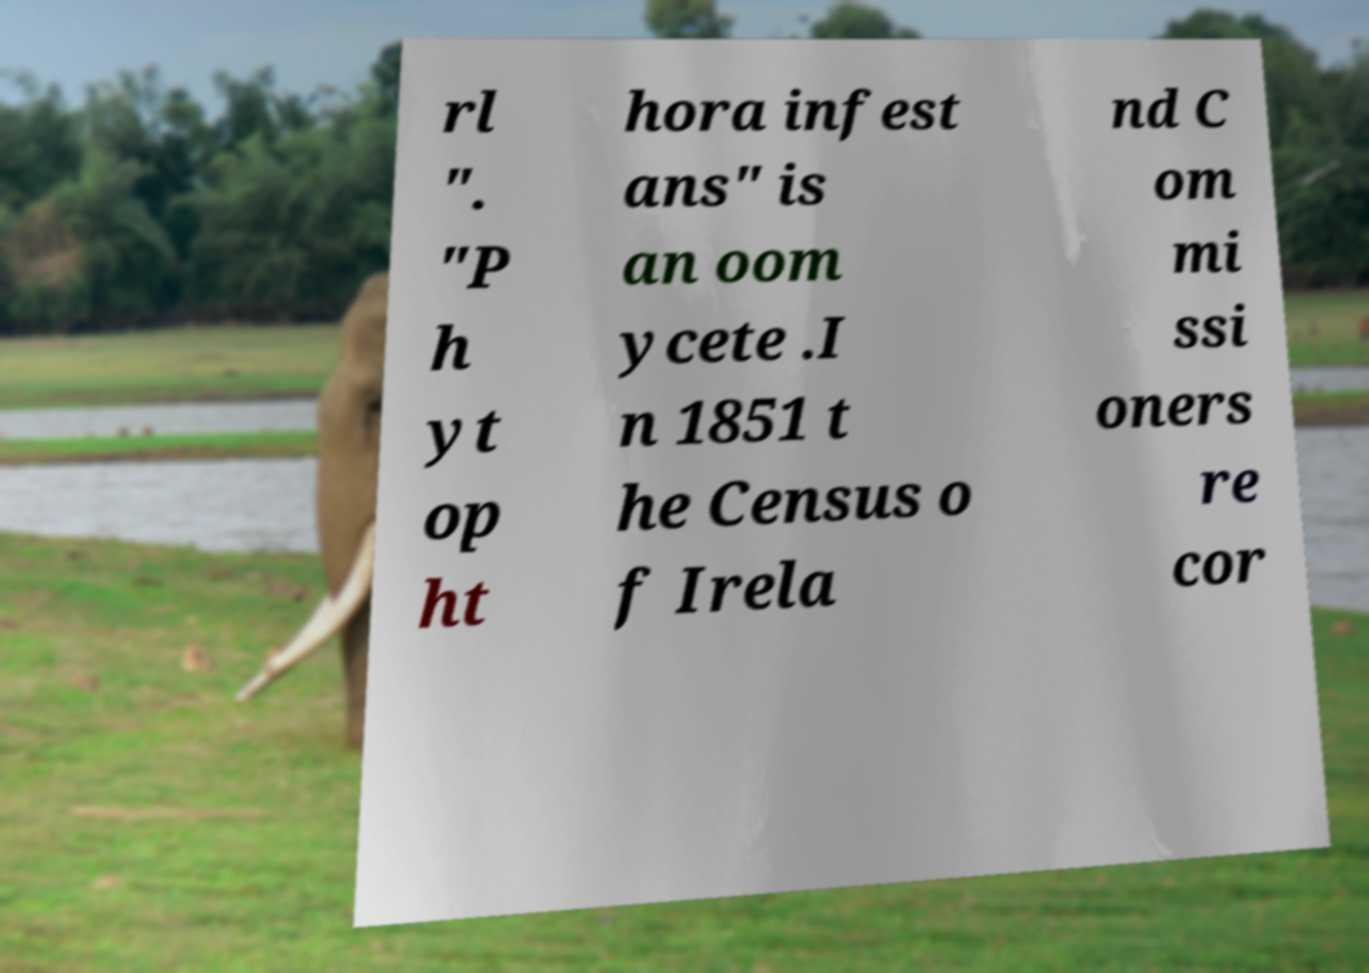Could you extract and type out the text from this image? rl ". "P h yt op ht hora infest ans" is an oom ycete .I n 1851 t he Census o f Irela nd C om mi ssi oners re cor 